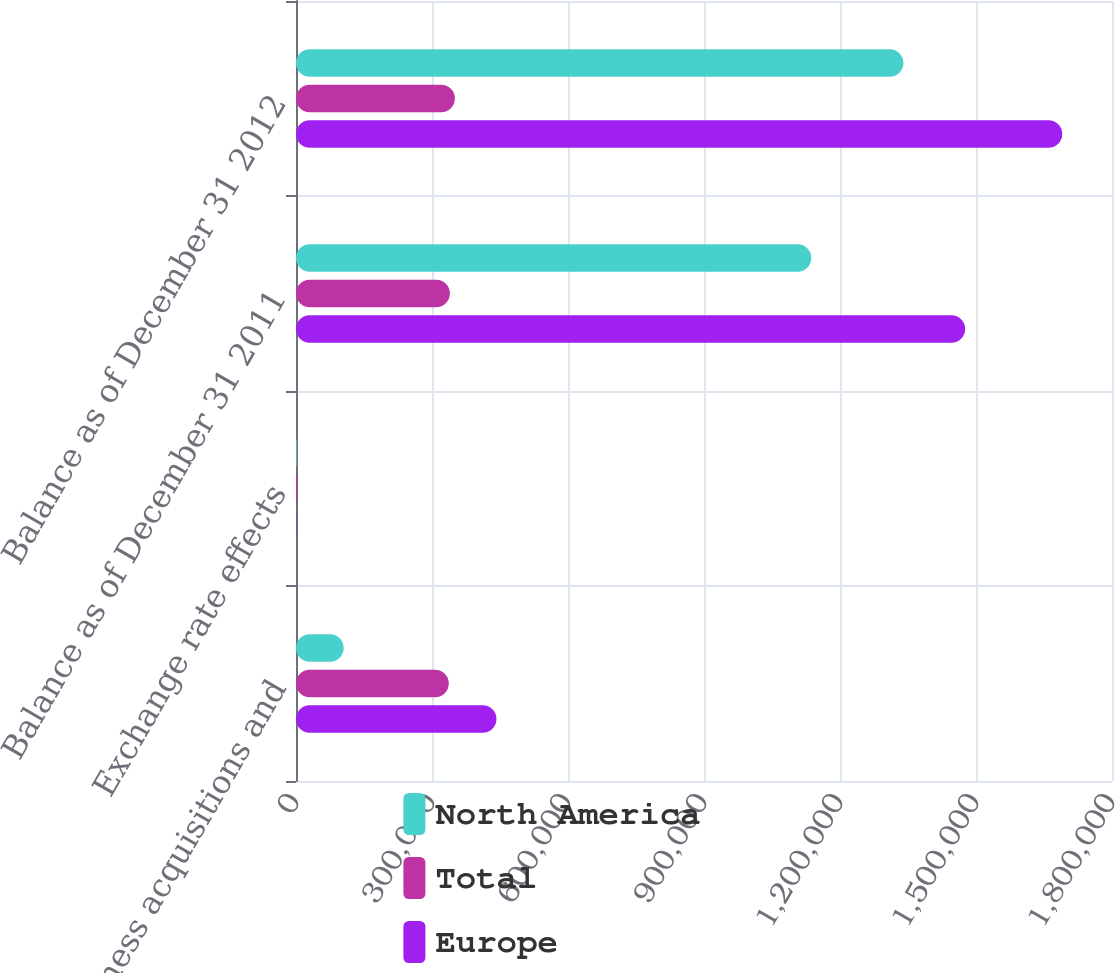<chart> <loc_0><loc_0><loc_500><loc_500><stacked_bar_chart><ecel><fcel>Business acquisitions and<fcel>Exchange rate effects<fcel>Balance as of December 31 2011<fcel>Balance as of December 31 2012<nl><fcel>North America<fcel>105177<fcel>1520<fcel>1.13663e+06<fcel>1.33983e+06<nl><fcel>Total<fcel>337031<fcel>2402<fcel>339433<fcel>350453<nl><fcel>Europe<fcel>442208<fcel>882<fcel>1.47606e+06<fcel>1.69028e+06<nl></chart> 